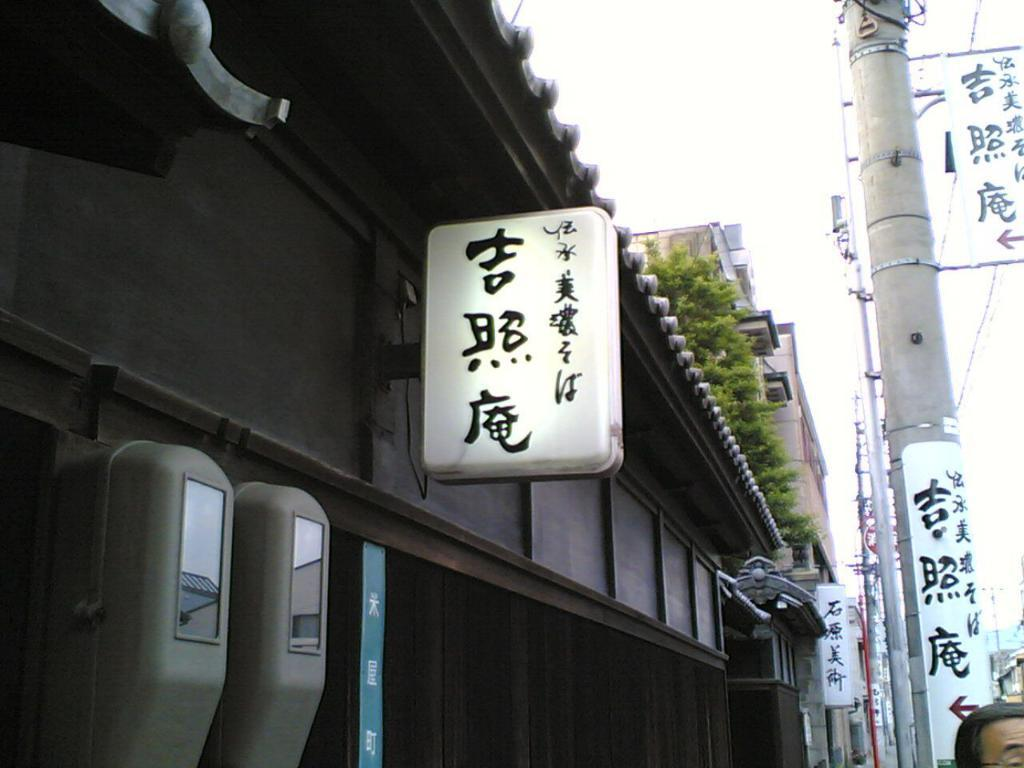What is the main subject of the image? There is a person's face in the image. What is the purpose of the name board in the image? The name board is likely used to identify the person or the location. What are the poles used for in the image? The poles might be used for support or as a part of a structure. What can be seen on the posters in the image? The content of the posters is not specified, but they are likely used for advertising or conveying information. What type of vegetation is present in the image? There are leaves in the image, which suggests the presence of plants or trees. What type of structures can be seen in the image? There are buildings in the image, which indicates an urban or developed area. What other objects are present in the image? There are some objects in the image, but their specific nature is not mentioned. What is visible in the background of the image? The sky is visible in the background of the image. What type of fang can be seen in the image? There is no fang present in the image. What type of canvas is used to create the image? The question assumes that the image is a painting or artwork, which is not specified in the facts provided. The image could be a photograph or a digital representation. 